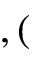Convert formula to latex. <formula><loc_0><loc_0><loc_500><loc_500>, (</formula> 